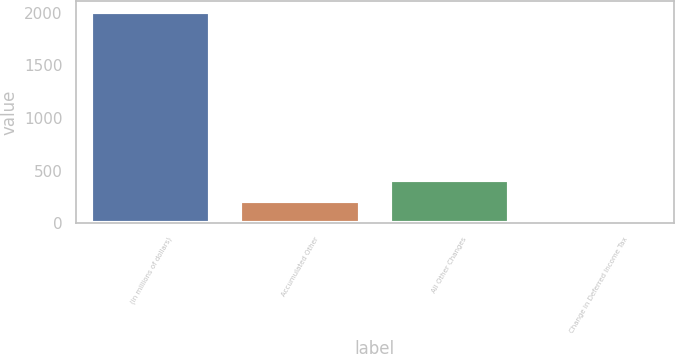Convert chart. <chart><loc_0><loc_0><loc_500><loc_500><bar_chart><fcel>(in millions of dollars)<fcel>Accumulated Other<fcel>All Other Changes<fcel>Change in Deferred Income Tax<nl><fcel>2010<fcel>209.73<fcel>409.76<fcel>9.7<nl></chart> 